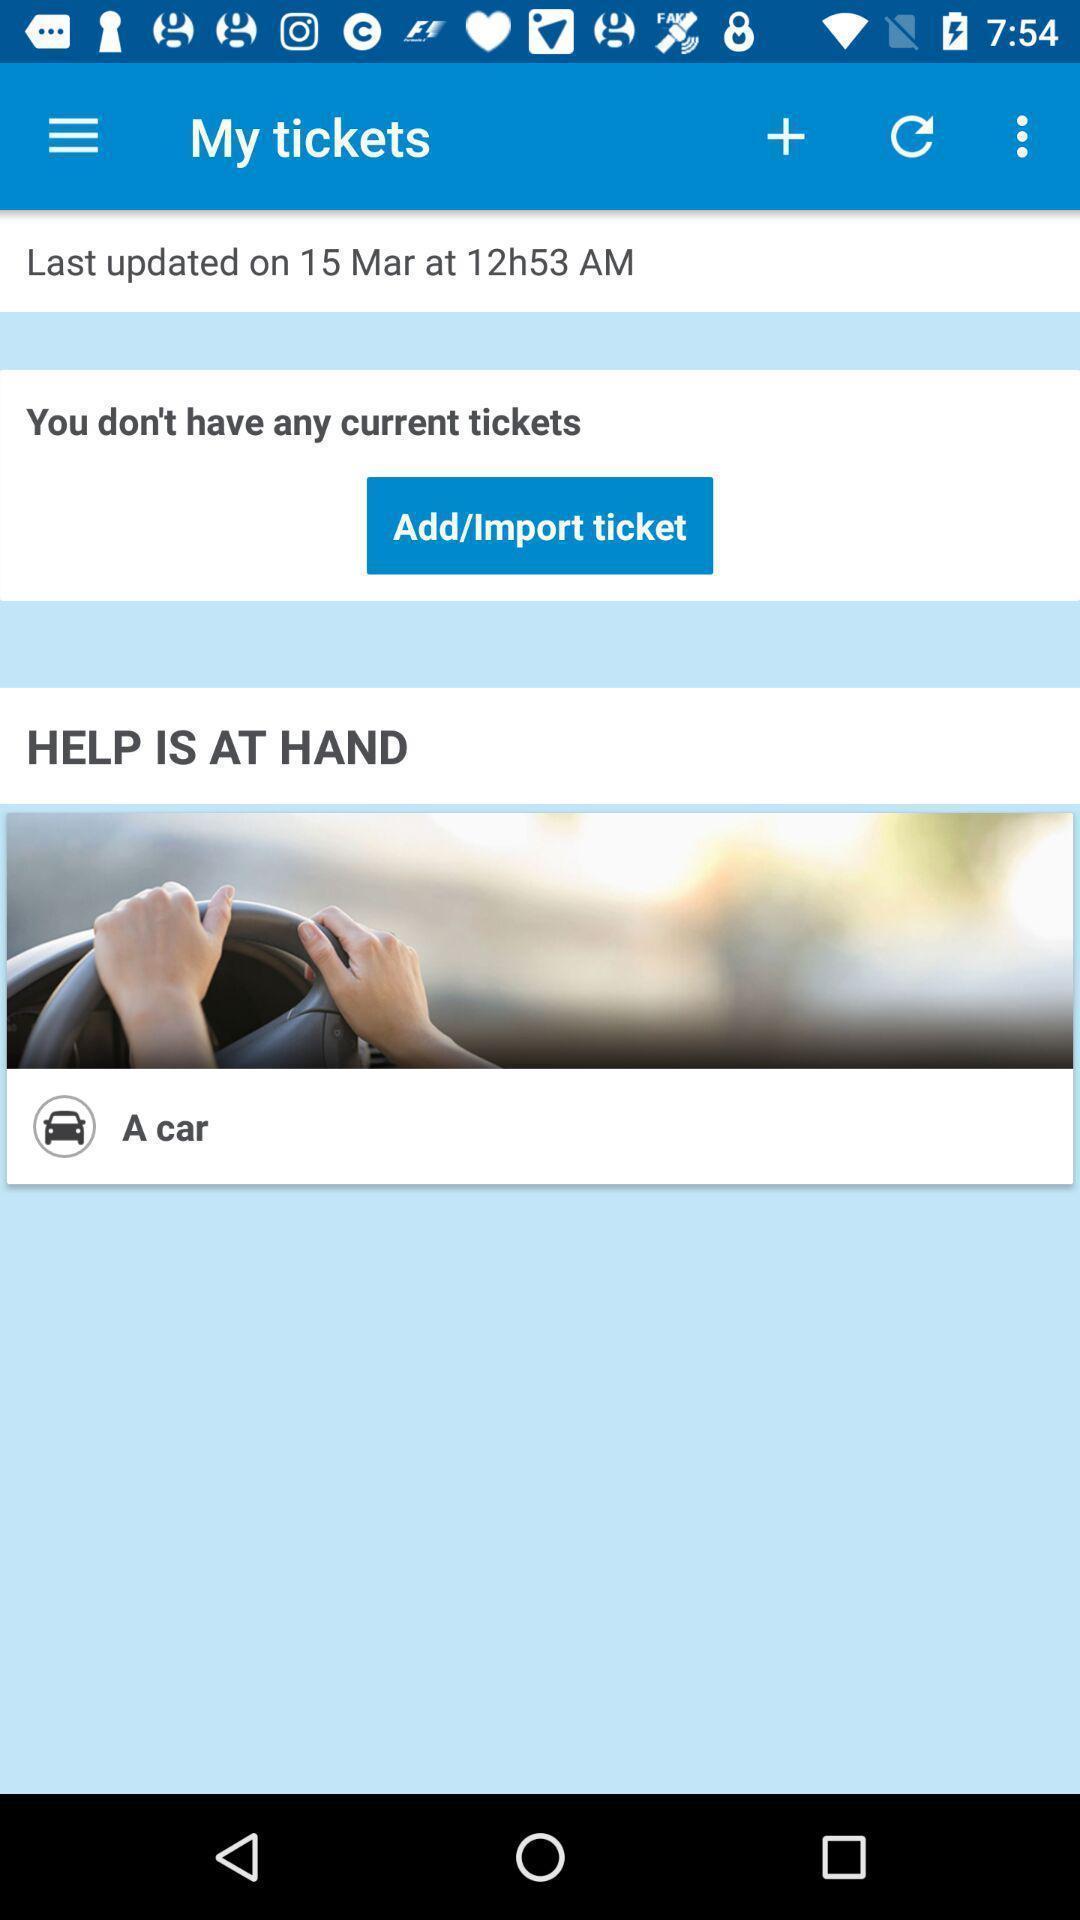Give me a narrative description of this picture. Screen page displaying booking status. 